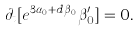<formula> <loc_0><loc_0><loc_500><loc_500>\partial _ { t } [ e ^ { 3 \alpha _ { 0 } + d \beta _ { 0 } } \beta _ { 0 } ^ { \prime } ] = 0 .</formula> 